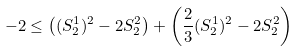Convert formula to latex. <formula><loc_0><loc_0><loc_500><loc_500>- 2 \leq \left ( ( S _ { 2 } ^ { 1 } ) ^ { 2 } - 2 S _ { 2 } ^ { 2 } \right ) + \left ( \frac { 2 } { 3 } ( S _ { 2 } ^ { 1 } ) ^ { 2 } - 2 S _ { 2 } ^ { 2 } \right )</formula> 